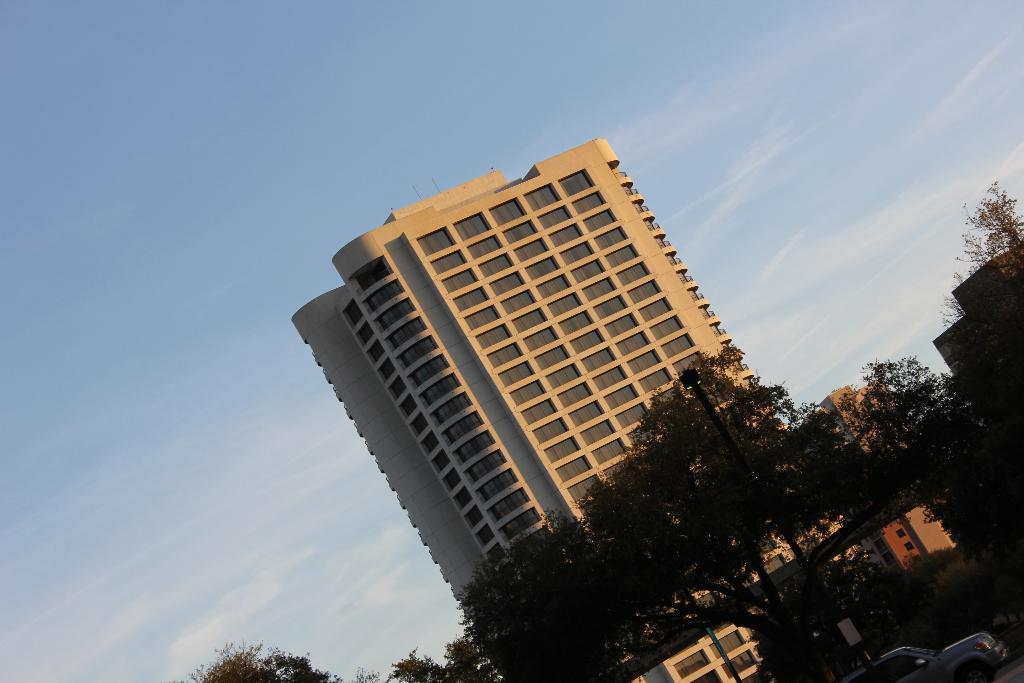What type of structure can be seen in the image? There is a building in the image. What other natural elements are present in the image? Trees are present in the image. Are there any man-made objects visible besides the building? Yes, vehicles are visible in the image. What can be seen in the sky in the image? The sky is visible in the image, and clouds are present. What type of neck can be seen on the trees in the image? There are no necks present on the trees in the image, as trees do not have necks. Can you tell me how many cans are visible in the image? There is no mention of cans in the image, so it is not possible to determine their presence or quantity. 